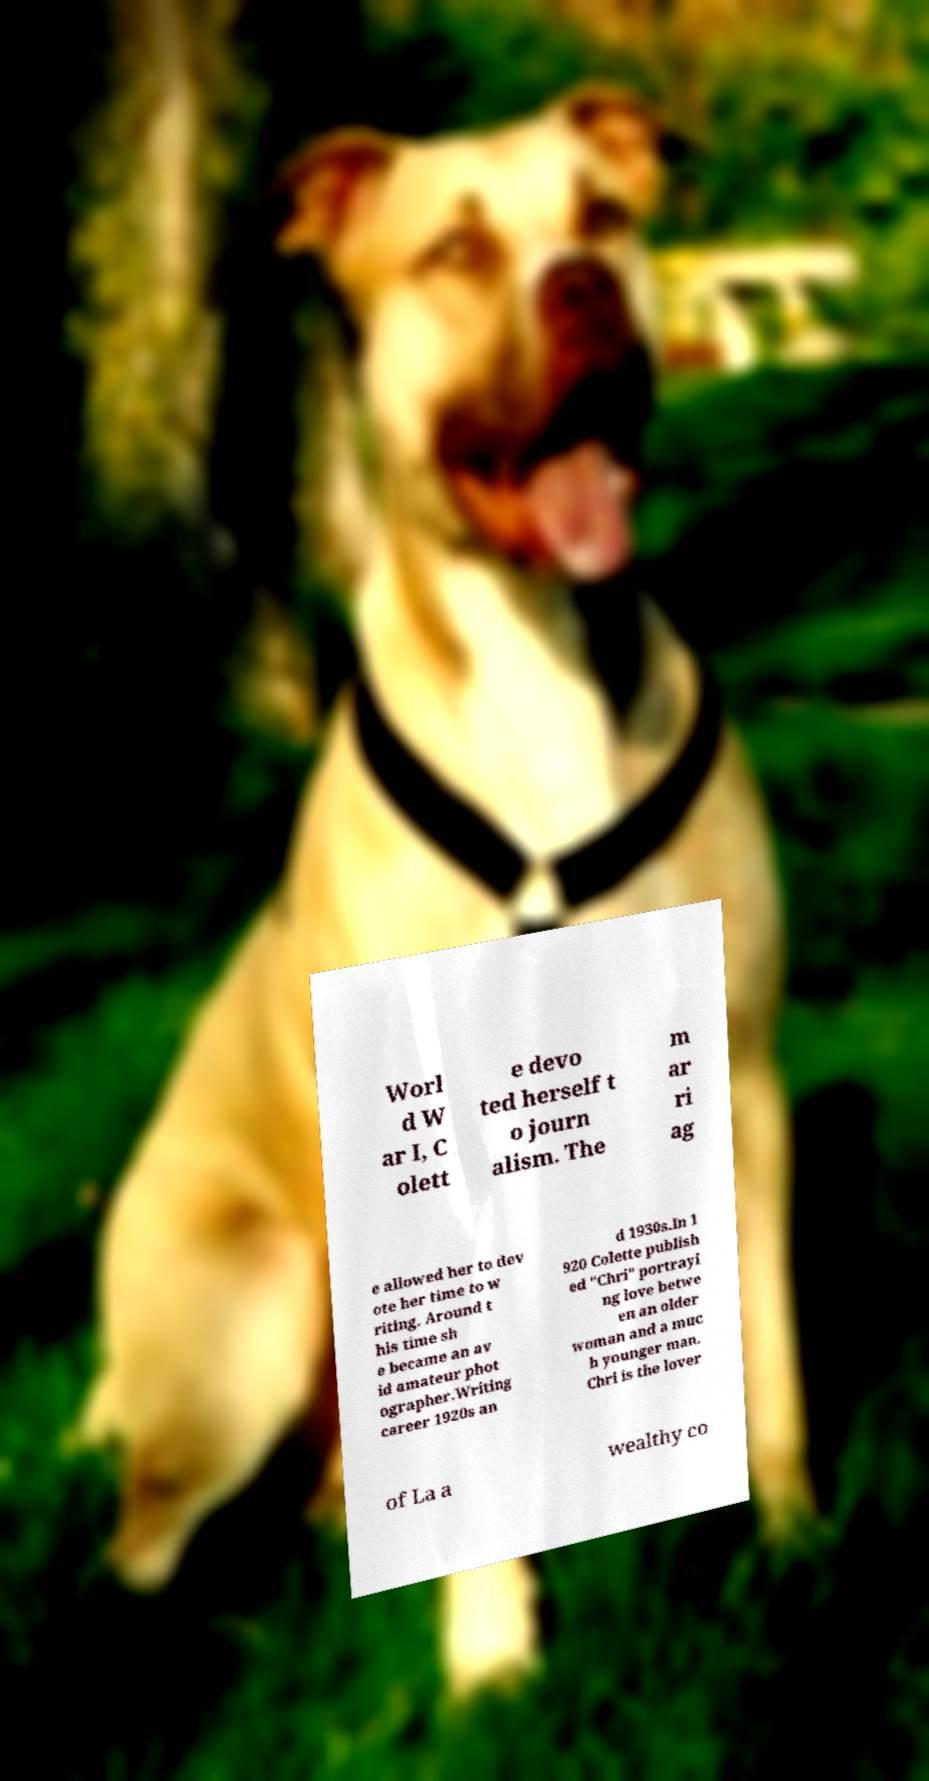What messages or text are displayed in this image? I need them in a readable, typed format. Worl d W ar I, C olett e devo ted herself t o journ alism. The m ar ri ag e allowed her to dev ote her time to w riting. Around t his time sh e became an av id amateur phot ographer.Writing career 1920s an d 1930s.In 1 920 Colette publish ed "Chri" portrayi ng love betwe en an older woman and a muc h younger man. Chri is the lover of La a wealthy co 